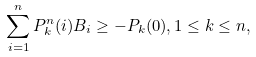Convert formula to latex. <formula><loc_0><loc_0><loc_500><loc_500>\sum _ { i = 1 } ^ { n } P _ { k } ^ { n } ( i ) B _ { i } \geq - P _ { k } ( 0 ) , 1 \leq k \leq n ,</formula> 